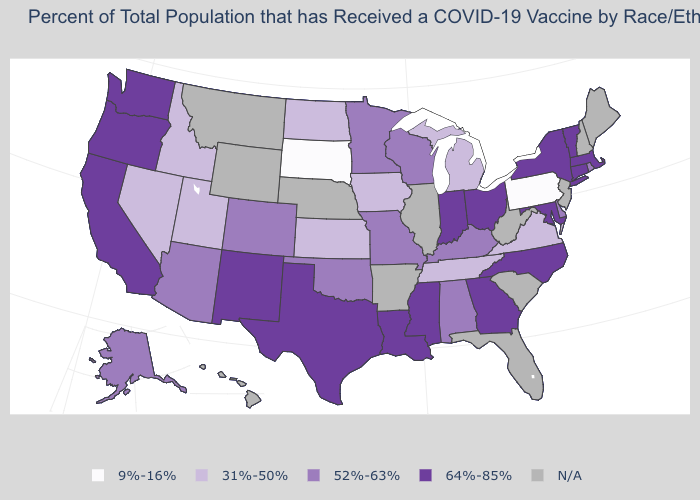Name the states that have a value in the range 31%-50%?
Answer briefly. Idaho, Iowa, Kansas, Michigan, Nevada, North Dakota, Tennessee, Utah, Virginia. What is the value of Michigan?
Write a very short answer. 31%-50%. What is the value of Connecticut?
Write a very short answer. 64%-85%. Among the states that border Missouri , does Kentucky have the lowest value?
Answer briefly. No. Is the legend a continuous bar?
Write a very short answer. No. What is the value of West Virginia?
Keep it brief. N/A. What is the value of North Carolina?
Answer briefly. 64%-85%. What is the lowest value in the MidWest?
Quick response, please. 9%-16%. Which states have the lowest value in the USA?
Quick response, please. Pennsylvania, South Dakota. What is the value of New Hampshire?
Concise answer only. N/A. Name the states that have a value in the range 31%-50%?
Keep it brief. Idaho, Iowa, Kansas, Michigan, Nevada, North Dakota, Tennessee, Utah, Virginia. What is the value of Nebraska?
Write a very short answer. N/A. Does Kentucky have the highest value in the USA?
Be succinct. No. 